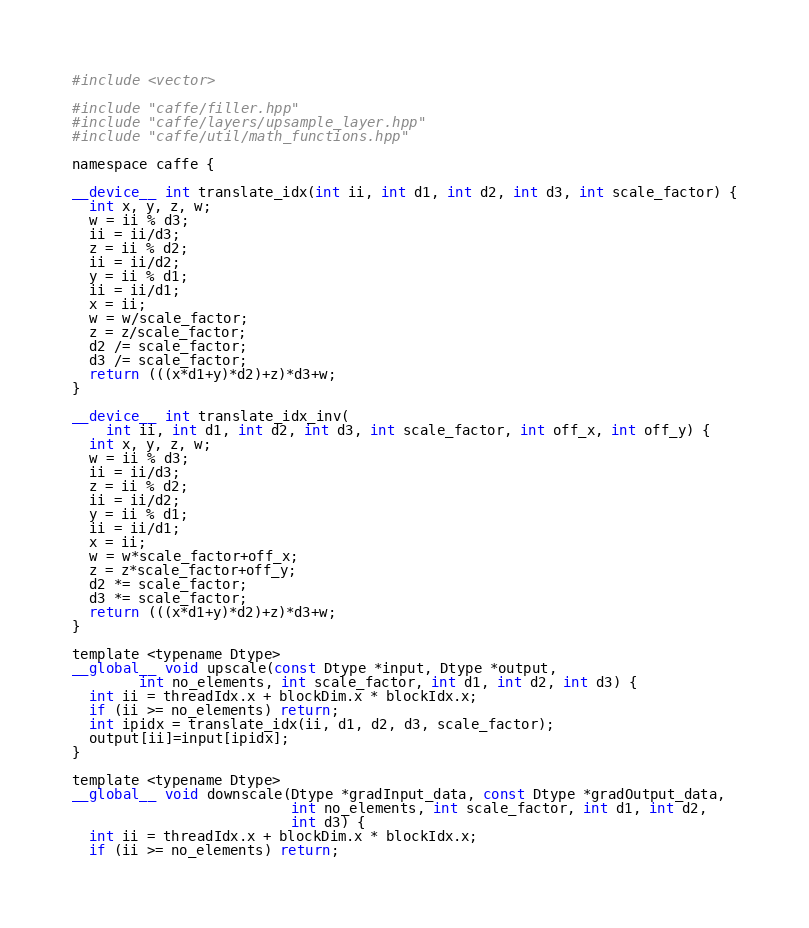Convert code to text. <code><loc_0><loc_0><loc_500><loc_500><_Cuda_>#include <vector>

#include "caffe/filler.hpp"
#include "caffe/layers/upsample_layer.hpp"
#include "caffe/util/math_functions.hpp"

namespace caffe {

__device__ int translate_idx(int ii, int d1, int d2, int d3, int scale_factor) {
  int x, y, z, w;
  w = ii % d3;
  ii = ii/d3;
  z = ii % d2;
  ii = ii/d2;
  y = ii % d1;
  ii = ii/d1;
  x = ii;
  w = w/scale_factor;
  z = z/scale_factor;
  d2 /= scale_factor;
  d3 /= scale_factor;
  return (((x*d1+y)*d2)+z)*d3+w;
}

__device__ int translate_idx_inv(
    int ii, int d1, int d2, int d3, int scale_factor, int off_x, int off_y) {
  int x, y, z, w;
  w = ii % d3;
  ii = ii/d3;
  z = ii % d2;
  ii = ii/d2;
  y = ii % d1;
  ii = ii/d1;
  x = ii;
  w = w*scale_factor+off_x;
  z = z*scale_factor+off_y;
  d2 *= scale_factor;
  d3 *= scale_factor;
  return (((x*d1+y)*d2)+z)*d3+w;
}

template <typename Dtype>
__global__ void upscale(const Dtype *input, Dtype *output,
        int no_elements, int scale_factor, int d1, int d2, int d3) {
  int ii = threadIdx.x + blockDim.x * blockIdx.x;
  if (ii >= no_elements) return;
  int ipidx = translate_idx(ii, d1, d2, d3, scale_factor);
  output[ii]=input[ipidx];
}

template <typename Dtype>
__global__ void downscale(Dtype *gradInput_data, const Dtype *gradOutput_data,
                          int no_elements, int scale_factor, int d1, int d2,
                          int d3) {
  int ii = threadIdx.x + blockDim.x * blockIdx.x;
  if (ii >= no_elements) return;</code> 